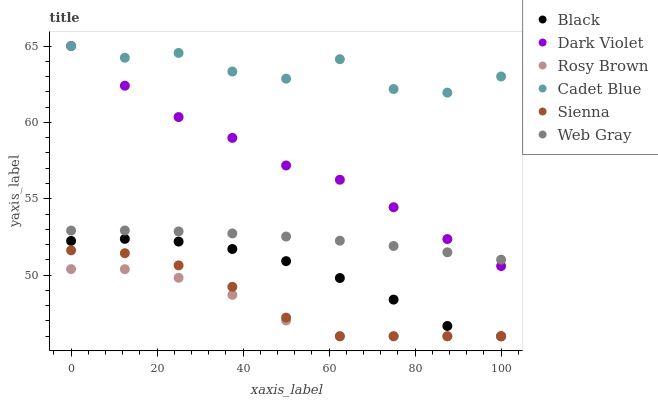Does Rosy Brown have the minimum area under the curve?
Answer yes or no. Yes. Does Cadet Blue have the maximum area under the curve?
Answer yes or no. Yes. Does Dark Violet have the minimum area under the curve?
Answer yes or no. No. Does Dark Violet have the maximum area under the curve?
Answer yes or no. No. Is Web Gray the smoothest?
Answer yes or no. Yes. Is Cadet Blue the roughest?
Answer yes or no. Yes. Is Rosy Brown the smoothest?
Answer yes or no. No. Is Rosy Brown the roughest?
Answer yes or no. No. Does Rosy Brown have the lowest value?
Answer yes or no. Yes. Does Dark Violet have the lowest value?
Answer yes or no. No. Does Dark Violet have the highest value?
Answer yes or no. Yes. Does Rosy Brown have the highest value?
Answer yes or no. No. Is Black less than Web Gray?
Answer yes or no. Yes. Is Web Gray greater than Black?
Answer yes or no. Yes. Does Cadet Blue intersect Dark Violet?
Answer yes or no. Yes. Is Cadet Blue less than Dark Violet?
Answer yes or no. No. Is Cadet Blue greater than Dark Violet?
Answer yes or no. No. Does Black intersect Web Gray?
Answer yes or no. No. 